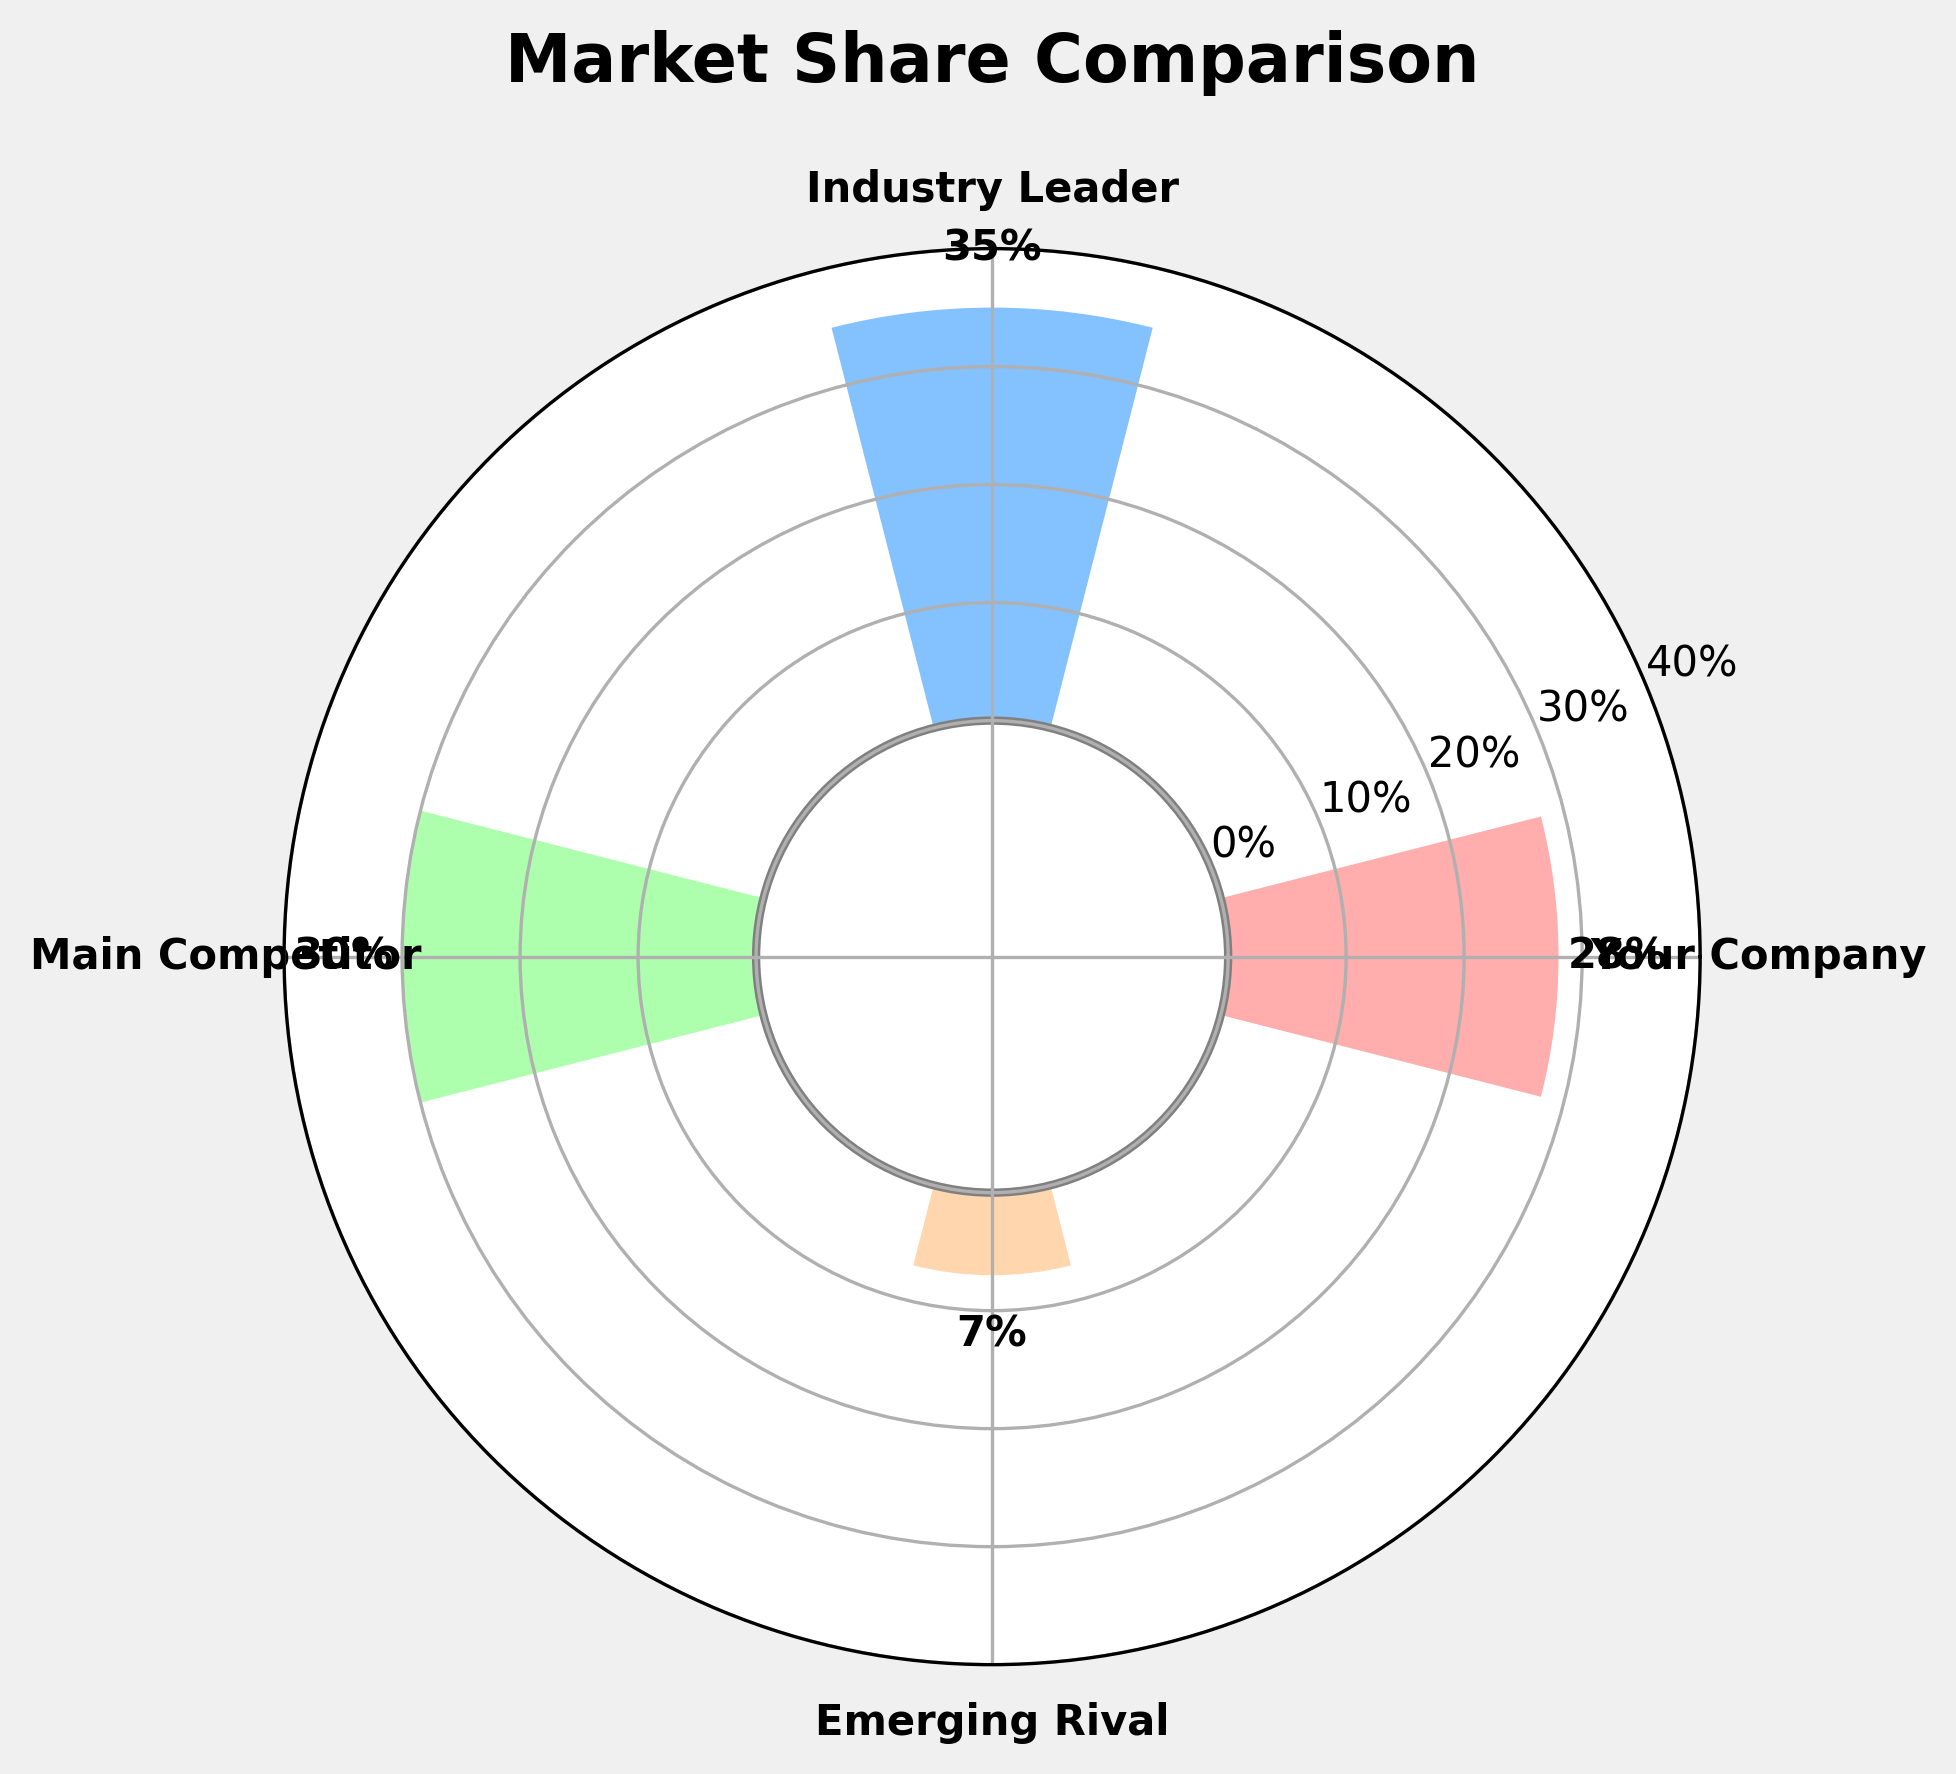What is the title of the chart? The title of the chart can be found at the top of the figure. It states the main purpose of the chart. In this case, it is written in bold and large fonts atop the figure.
Answer: Market Share Comparison How many companies are represented in the chart? The number of companies represented can be identified by counting the number of bar segments or the number of labels around the chart perimeter. Here, each color represents a different company, and there are distinct company labels.
Answer: 4 What is the range of values displayed on the y-axis? The y-axis values can be picked by observing the minimum and maximum labels displayed around the inner circle. This includes all the ticks from the bottom limit to the topmost point.
Answer: 0% to 40% What market share does the "Main Competitor" have? Locate the "Main Competitor" label on the chart and identify its corresponding bar. The value is indicated near the top of the bar.
Answer: 30% How much higher is the market share of the "Industry Leader" compared to "Emerging Rival"? First, locate the market shares for the "Industry Leader" and "Emerging Rival". Subtract the market share of the "Emerging Rival" from the market share of the "Industry Leader".
Answer: 28% What is the combined market share of "Your Company" and "Main Competitor"? Identify the market shares for "Your Company" and "Main Competitor". Add these two values together to get the combined market share.
Answer: 58% Which company has the smallest market share and how much is it? Identify the company with the shortest bar representing the market share. The company name is labeled at the angle corresponding to the shortest bar.
Answer: Emerging Rival, 7% How does the market share of "Your Company" compare to the "Main Competitor"? Identify the market shares of both "Your Company" and "Main Competitor". Compare the two values to determine which one is higher.
Answer: Main Competitor has a 2% higher market share than Your Company What are the colors representing each company? Look at each bar's color and match it with the corresponding company's label to identify the colors used.
Answer: Your Company: Light Red, Industry Leader: Light Blue, Main Competitor: Light Green, Emerging Rival: Light Orange What is the percentage difference between "Industry Leader" and "Your Company"? Find the market shares of "Industry Leader" and "Your Company". Subtract the latter from the former and calculate the difference as a percentage.
Answer: 7% 